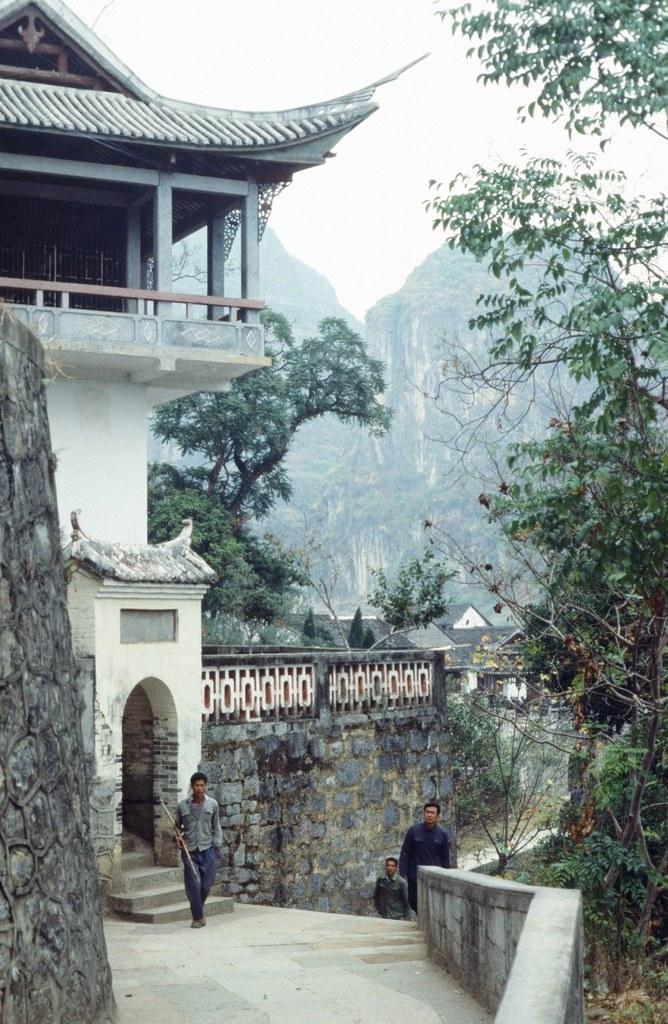How would you summarize this image in a sentence or two? In this picture there is a house on the left side of the image and there are people in the center of the image and there are trees on the right and left side of the image. 